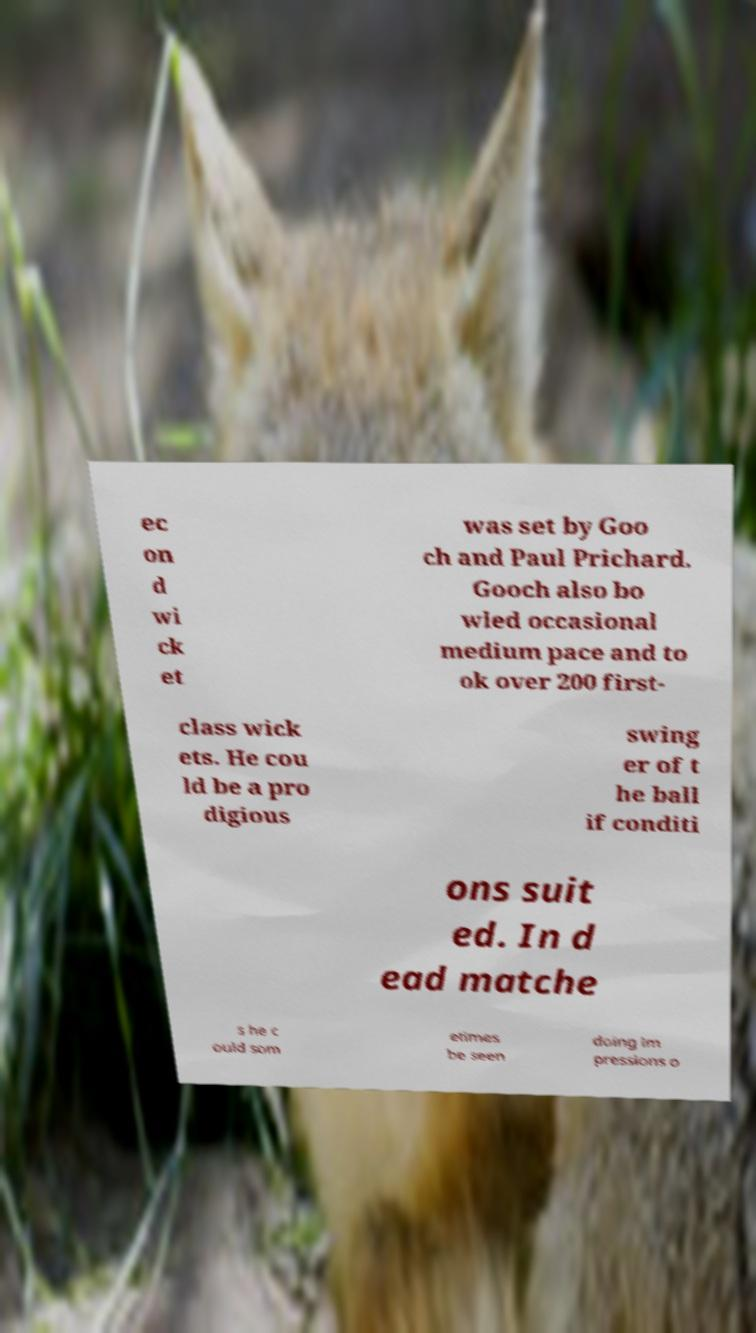I need the written content from this picture converted into text. Can you do that? ec on d wi ck et was set by Goo ch and Paul Prichard. Gooch also bo wled occasional medium pace and to ok over 200 first- class wick ets. He cou ld be a pro digious swing er of t he ball if conditi ons suit ed. In d ead matche s he c ould som etimes be seen doing im pressions o 